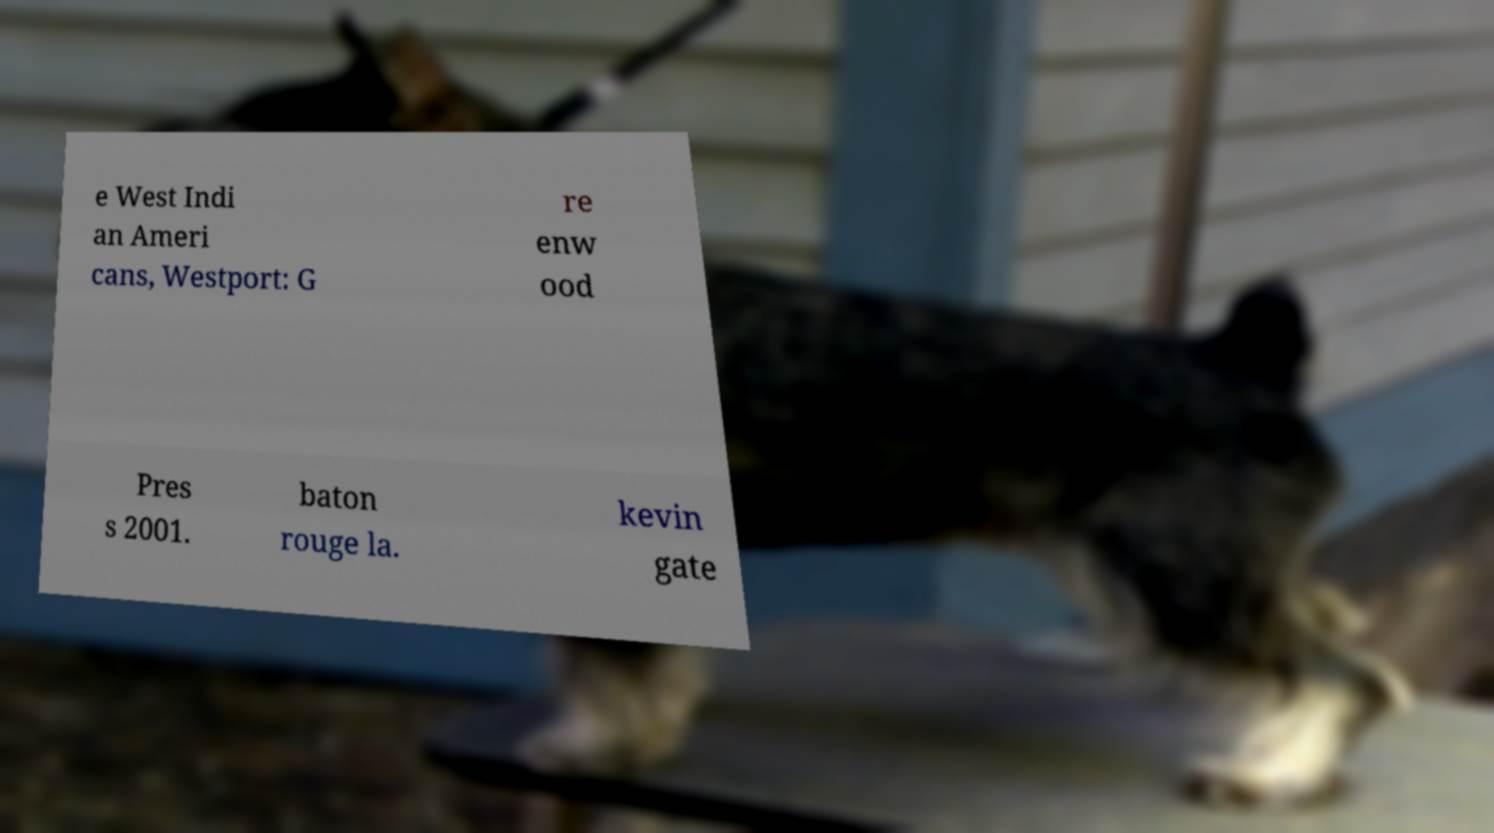Could you assist in decoding the text presented in this image and type it out clearly? e West Indi an Ameri cans, Westport: G re enw ood Pres s 2001. baton rouge la. kevin gate 